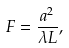<formula> <loc_0><loc_0><loc_500><loc_500>F = \frac { a ^ { 2 } } { \lambda L } ,</formula> 